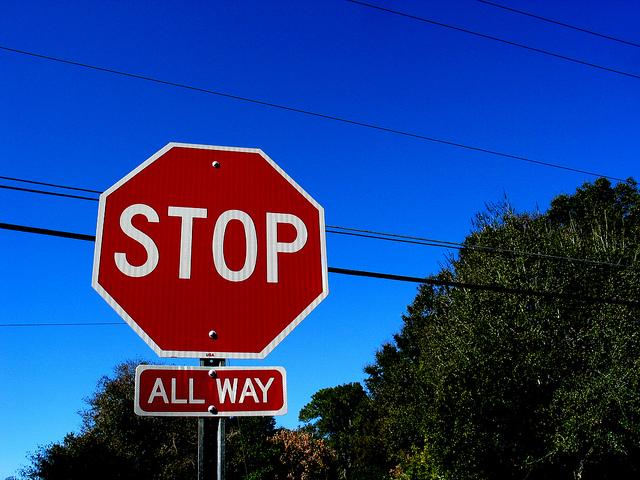How many wires?
Answer briefly. 6. Who has to stop?
Be succinct. Everyone. Are there leaves on the tree?
Give a very brief answer. Yes. Is there a person visible in this picture?
Quick response, please. No. Is this a city scene?
Be succinct. No. What color is the sign?
Give a very brief answer. Red. Is the sign faded?
Write a very short answer. No. 